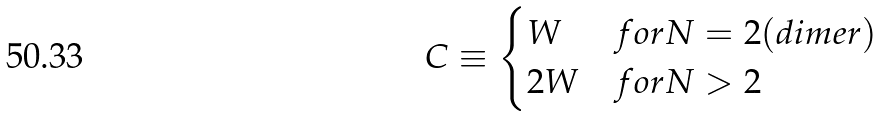Convert formula to latex. <formula><loc_0><loc_0><loc_500><loc_500>C \equiv \begin{cases} W & f o r N = 2 ( d i m e r ) \\ 2 W & f o r N > 2 \end{cases}</formula> 